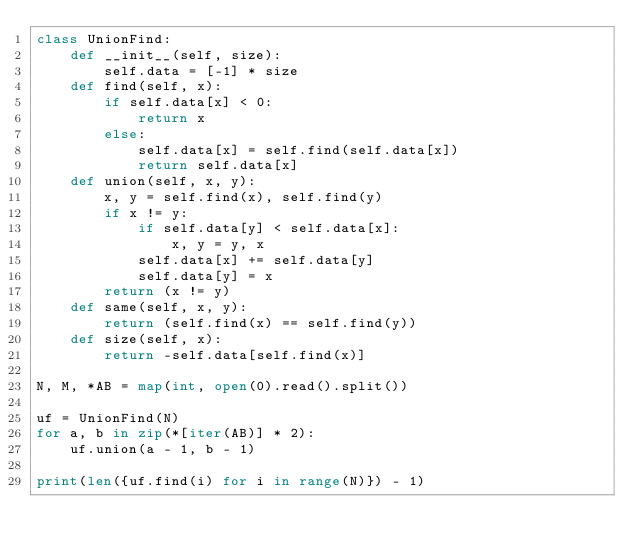<code> <loc_0><loc_0><loc_500><loc_500><_Python_>class UnionFind:
    def __init__(self, size):
        self.data = [-1] * size
    def find(self, x):
        if self.data[x] < 0:
            return x
        else:
            self.data[x] = self.find(self.data[x])
            return self.data[x]
    def union(self, x, y):
        x, y = self.find(x), self.find(y)
        if x != y:
            if self.data[y] < self.data[x]:
                x, y = y, x
            self.data[x] += self.data[y]
            self.data[y] = x
        return (x != y)
    def same(self, x, y):
        return (self.find(x) == self.find(y))
    def size(self, x):
        return -self.data[self.find(x)]

N, M, *AB = map(int, open(0).read().split())

uf = UnionFind(N)
for a, b in zip(*[iter(AB)] * 2):
    uf.union(a - 1, b - 1)

print(len({uf.find(i) for i in range(N)}) - 1)</code> 